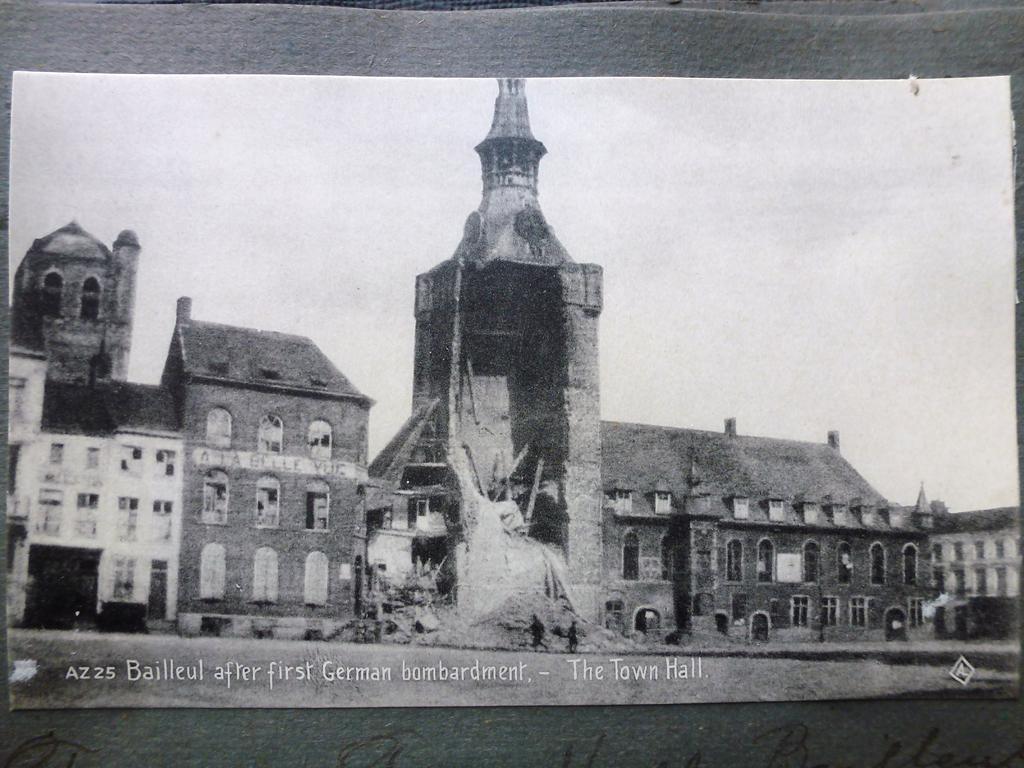What is the main subject in the center of the image? There is a poster in the center of the image. What types of images are featured on the poster? The poster contains images of buildings, windows, and poles. Are there any people depicted on the poster? Yes, two people are walking in the poster. Can you describe any additional features of the image? There is a watermark at the bottom of the image. What type of dress is the person wearing in the image? There are no people present in the image; it only features a poster with images of buildings, windows, and poles. How does the person's anger affect the buildings in the image? There is no person present in the image, and therefore no anger can be observed. 